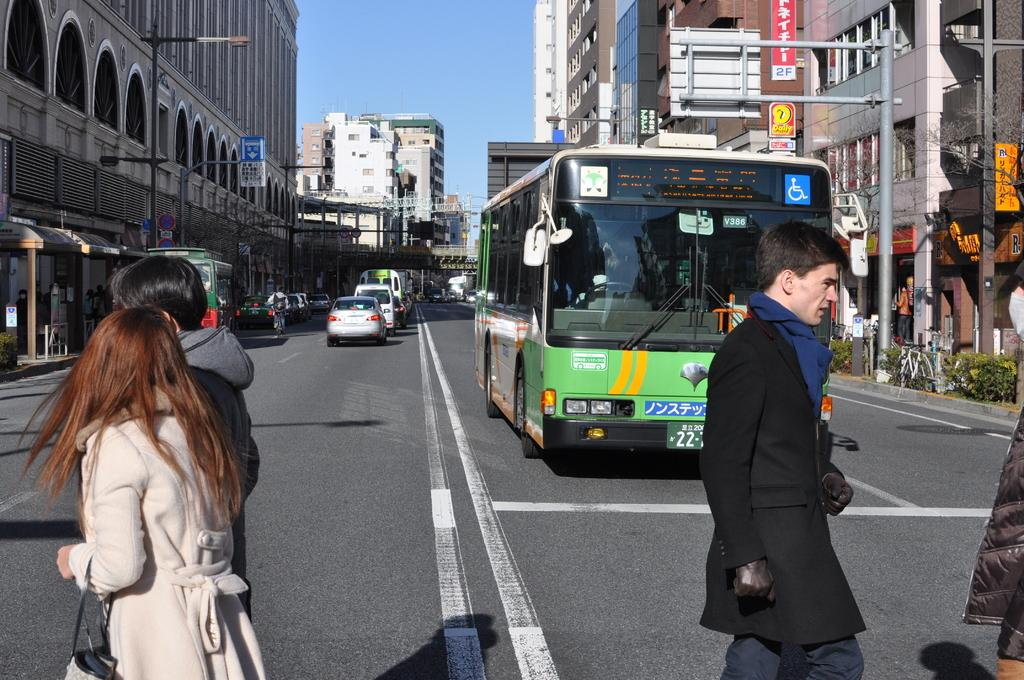<image>
Present a compact description of the photo's key features. A city street with a green bus with V386 on windshield. 